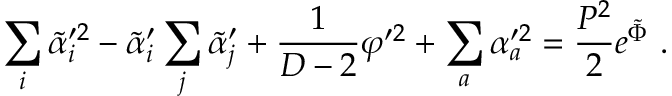Convert formula to latex. <formula><loc_0><loc_0><loc_500><loc_500>\sum _ { i } \tilde { \alpha } _ { i } ^ { \prime 2 } - \tilde { \alpha } _ { i } ^ { \prime } \sum _ { j } \tilde { \alpha } _ { j } ^ { \prime } + { \frac { 1 } { D - 2 } } \varphi ^ { \prime 2 } + \sum _ { a } \alpha _ { a } ^ { \prime 2 } = { \frac { P ^ { 2 } } { 2 } } e ^ { \tilde { \Phi } } \ .</formula> 